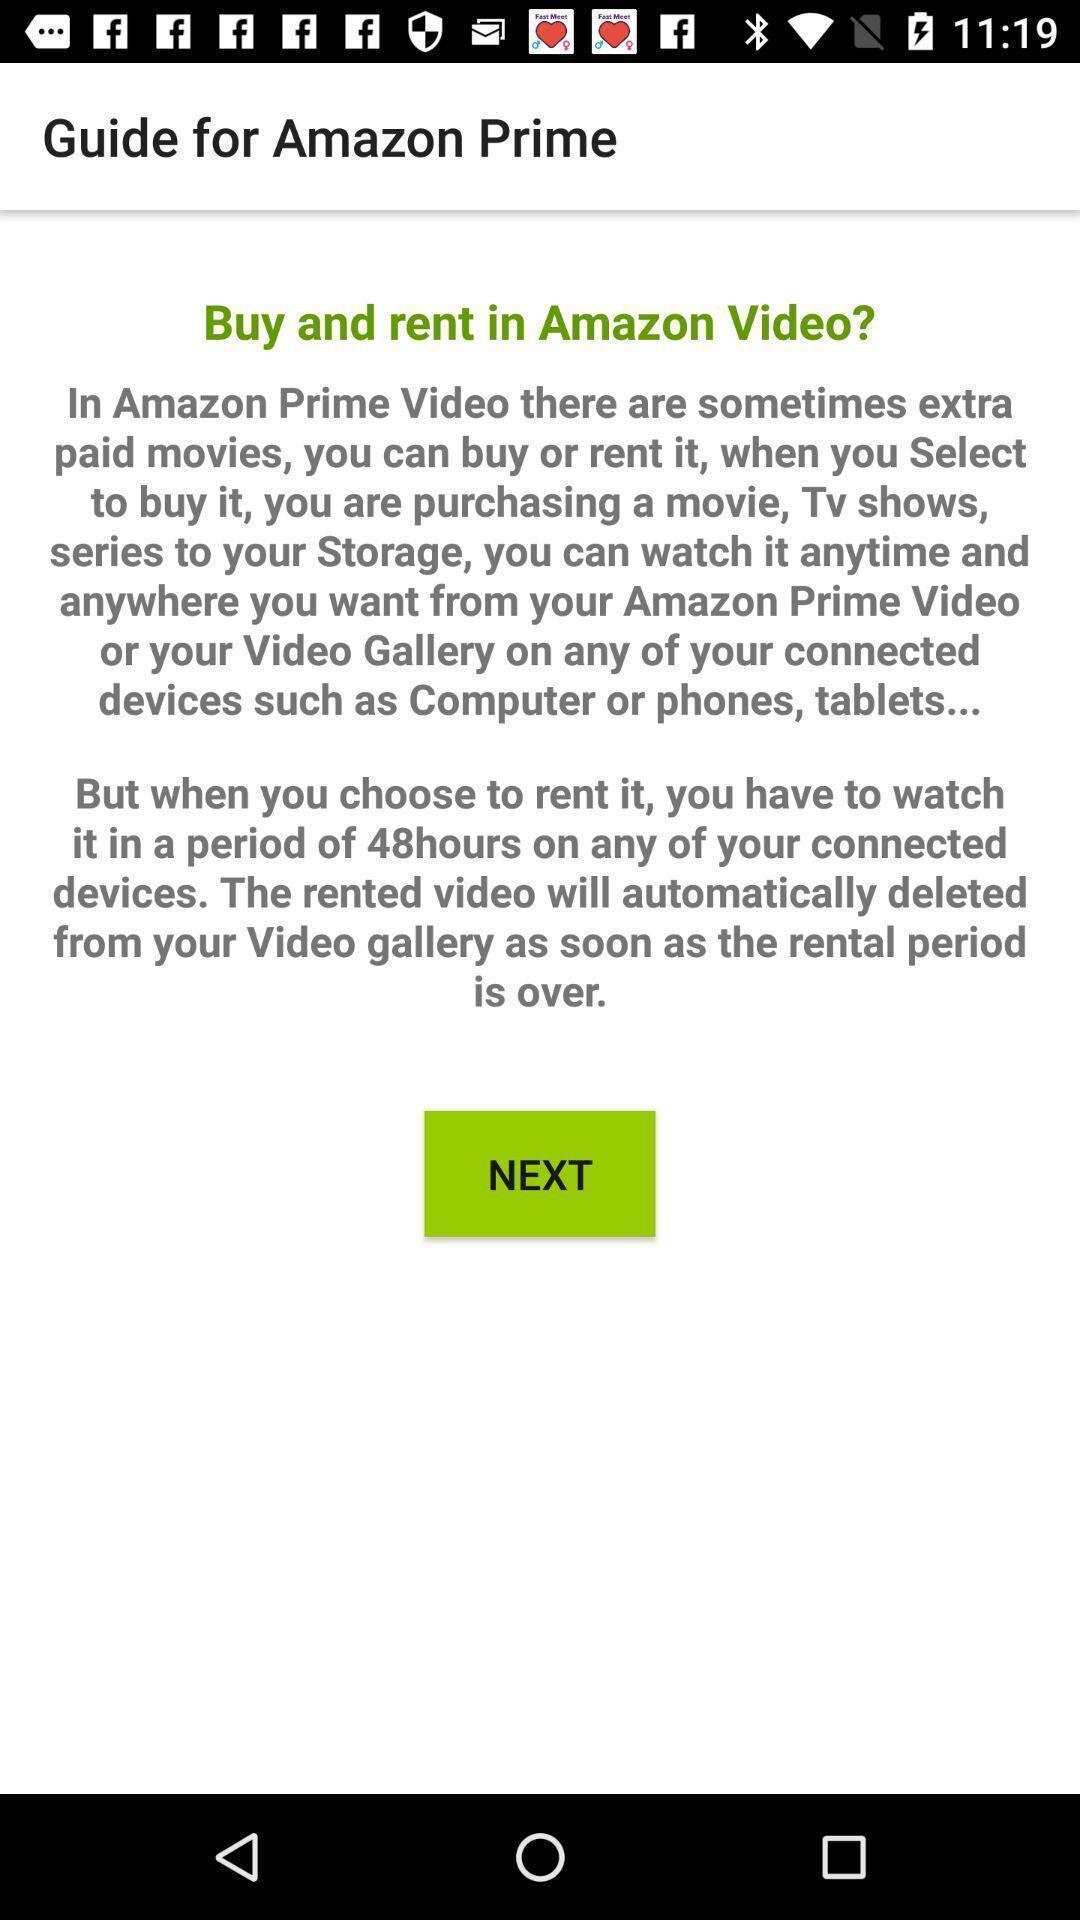Please provide a description for this image. Welcome page of an entertainment app. 